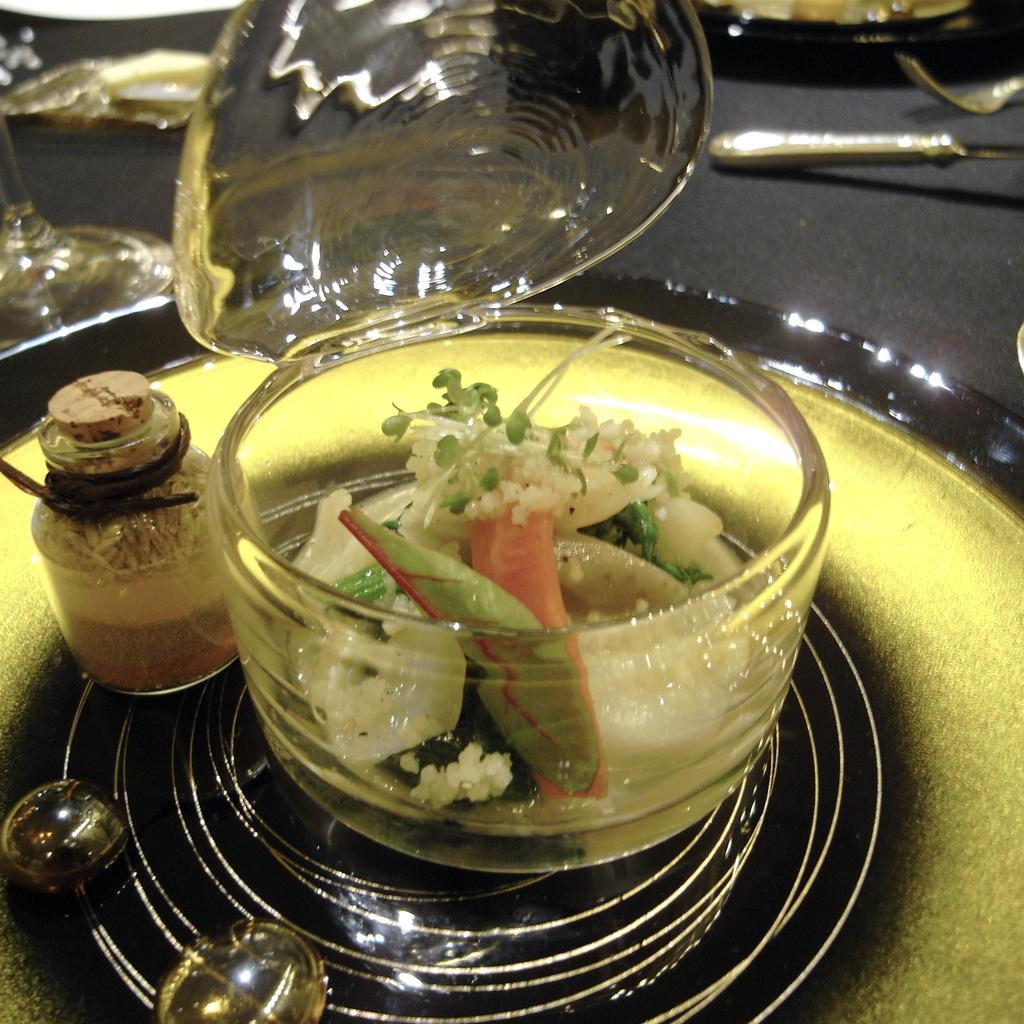Can you describe this image briefly? In the image in the center, we can see one table. On the table, there is a plate, bowl, jar, glass, some food item and a few other objects. 